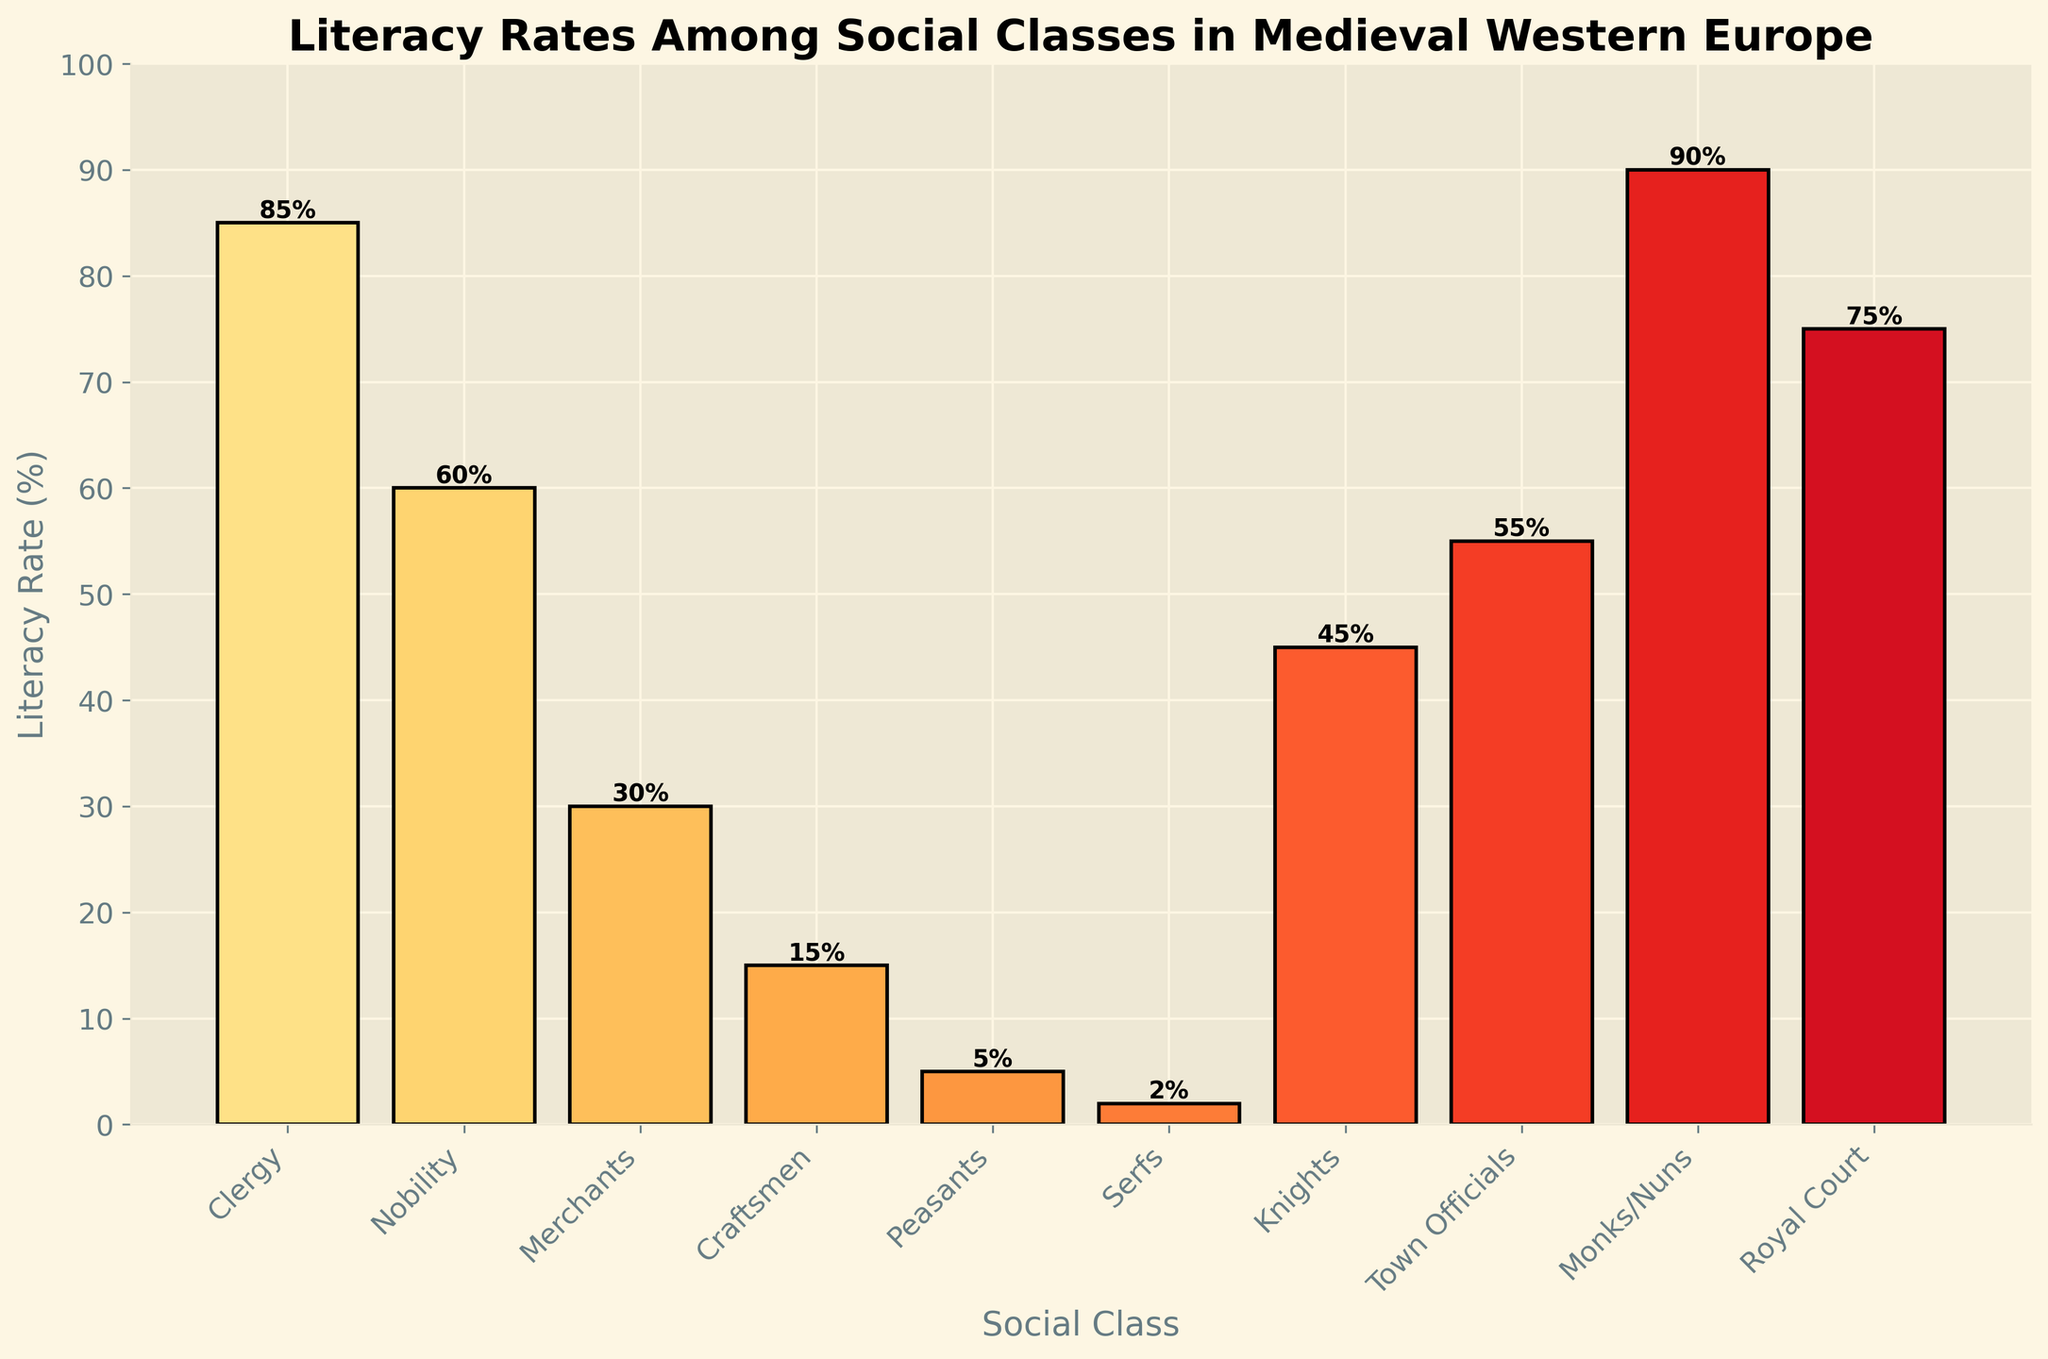Which social class has the highest literacy rate? The bar corresponding to "Monks/Nuns" is the tallest in the figure, indicating the highest literacy rate.
Answer: Monks/Nuns What is the difference in literacy rates between the Clergy and the Nobility? The literacy rate for the Clergy is 85%, and for the Nobility, it is 60%. The difference is 85% - 60%.
Answer: 25% Which social class has the lowest literacy rate? The bar corresponding to "Serfs" is the shortest in the figure, indicating the lowest literacy rate.
Answer: Serfs How many classes have a literacy rate above 50%? The bars corresponding to "Clergy," "Nobility," "Monks/Nuns," "Royal Court," and "Town Officials" are all above 50%.
Answer: 5 Is the literacy rate for Merchants higher or lower than that for Craftsmen? The bar for Merchants (30%) is taller than the bar for Craftsmen (15%).
Answer: Higher What is the average literacy rate among the Clergy, Nobility, and Knights? The literacy rates for the Clergy, Nobility, and Knights are 85%, 60%, and 45%, respectively. The average is (85% + 60% + 45%) / 3.
Answer: 63.33% Are there more social classes with a literacy rate above or below 30%? Classes above 30%: Clergy, Nobility, Monks/Nuns, Royal Court, Knights, and Town Officials (6 classes). Classes below 30%: Merchants, Craftsmen, Peasants, Serfs (4 classes).
Answer: Above What is the combined literacy rate for the Royal Court and Town Officials? The literacy rates for the Royal Court and Town Officials are 75% and 55%, respectively. The combined rate is 75% + 55%.
Answer: 130% Which two social classes have the closest literacy rates? The literacy rates for Nobility (60%) and Town Officials (55%) are closest, with a difference of 5%.
Answer: Nobility and Town Officials Identify the social class with a literacy rate exactly midway between Peasants and Clergy. Peasants have 5% and Clergy have 85%. Midway is (85% - 5%) / 2 + 5% = 45%. The class with 45% is Knights.
Answer: Knights 